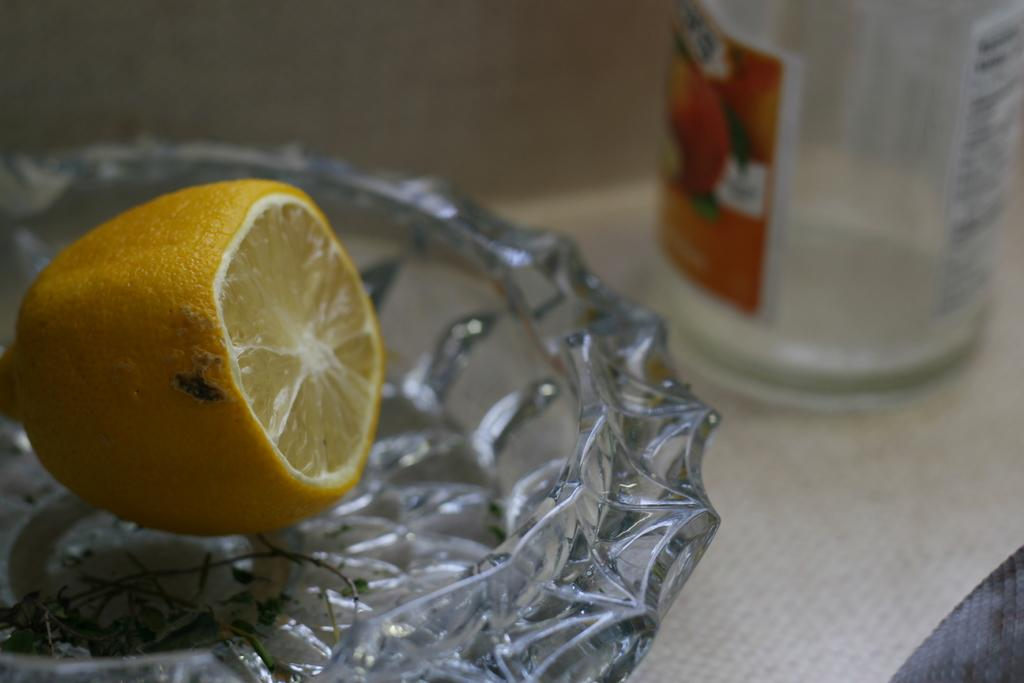What fruit is in the bowl on the left side of the image? There is a lemon in a bowl on the left side of the image. What material is the bowl made of? The bowl is made of glass. What other object is near the bowl? There is a bottle beside the bowl. What type of paint is being used to create a basket in the image? There is no paint or basket present in the image. What kind of apparatus is being used to squeeze the lemon in the image? There is no apparatus visible in the image; the lemon is simply in a bowl. 